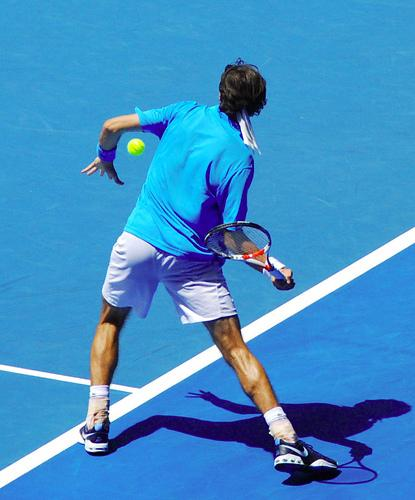What is the activity taking place in the image, and who is performing it? A man is playing tennis, holding a racquet behind his back. Can you name the logos or trademarks visible on the tennis player's gear? A Nike logo is visible on the shoe in the image. What can be inferred about the tennis player's emotions or state of mind from the image? It is difficult to infer the tennis player's emotions or state of mind as there is no clear facial expression or body language indication from the bounding box information. Count the number of tennis balls visible in the image. There are two tennis balls in the image. Identify the accessories worn by the tennis player in the image. A white wristband, a white band in the hair, a brace on the ankle, and a pair of black and white tennis shoes. Describe the scene happening on the tennis court in the image. A man playing tennis is ready to hit a green ball, while his shadow appears on the court and he has various sportswear and accessories. What is the main color of the tennis player's shirt in the image? The main color of the tennis player's shirt is blue. What are the two types of leg wear for the tennis player in the image? White shorts and leg brace Provide a detailed event description of what is happening in the image. A man playing tennis, wearing a blue shirt, white shorts, and a white band in his hair, is preparing to hit a green tennis ball with his black and white tennis racket. Is there a pink hairband on the person's head? No, it's not mentioned in the image. Based on the given information, create an imaginative story involving the tennis player and his environment. Once upon a time, a determined tennis player was competing in a championship match. His Nike shoes gave him an extra spring in his step, and he leaped for every ball with the graceful agility of a panther. Wearing a blue shirt that stood out against the bright court, he swung his black and white racquet with power and precision. As the intense match continued, his white wristband and headband aided in keeping him cool and focused. Amidst the crowd's cheers, he emerged victorious, and fans marveled at his incredible game. What type of accessory is worn by the tennis player on their ankle? Brace What is the activity that the man in the image is participating in? Playing tennis Is the tennis player wearing a wristband? If yes, what is its color? Yes, white wristband Can you describe the muscle visible on the tennis player's leg? Calf muscle Choose the correct object that is in front of the tennis player: (A) a basketball (B) a football (C) a tennis ball (C) a tennis ball What accessory is the tennis player wearing on their head? White band Identify the color of the tennis ball in the air. Green Describe the color and type of the tennis player's shirt. Blue shirt Describe the footwear of the tennis player. Black and white tennis shoes Given the objects and activities in the image, is it plausible that this is a basketball game? No Can you see the tennis player's shadow on the court? Yes What type of surface is featured in the image of the tennis event? Tennis court Which object in the image is indicative of the ongoing activity? Tennis racquet Identify the object that is positioned behind the man's back. Racquet Which logo is visible on the shoe of the tennis player? Nike logo 